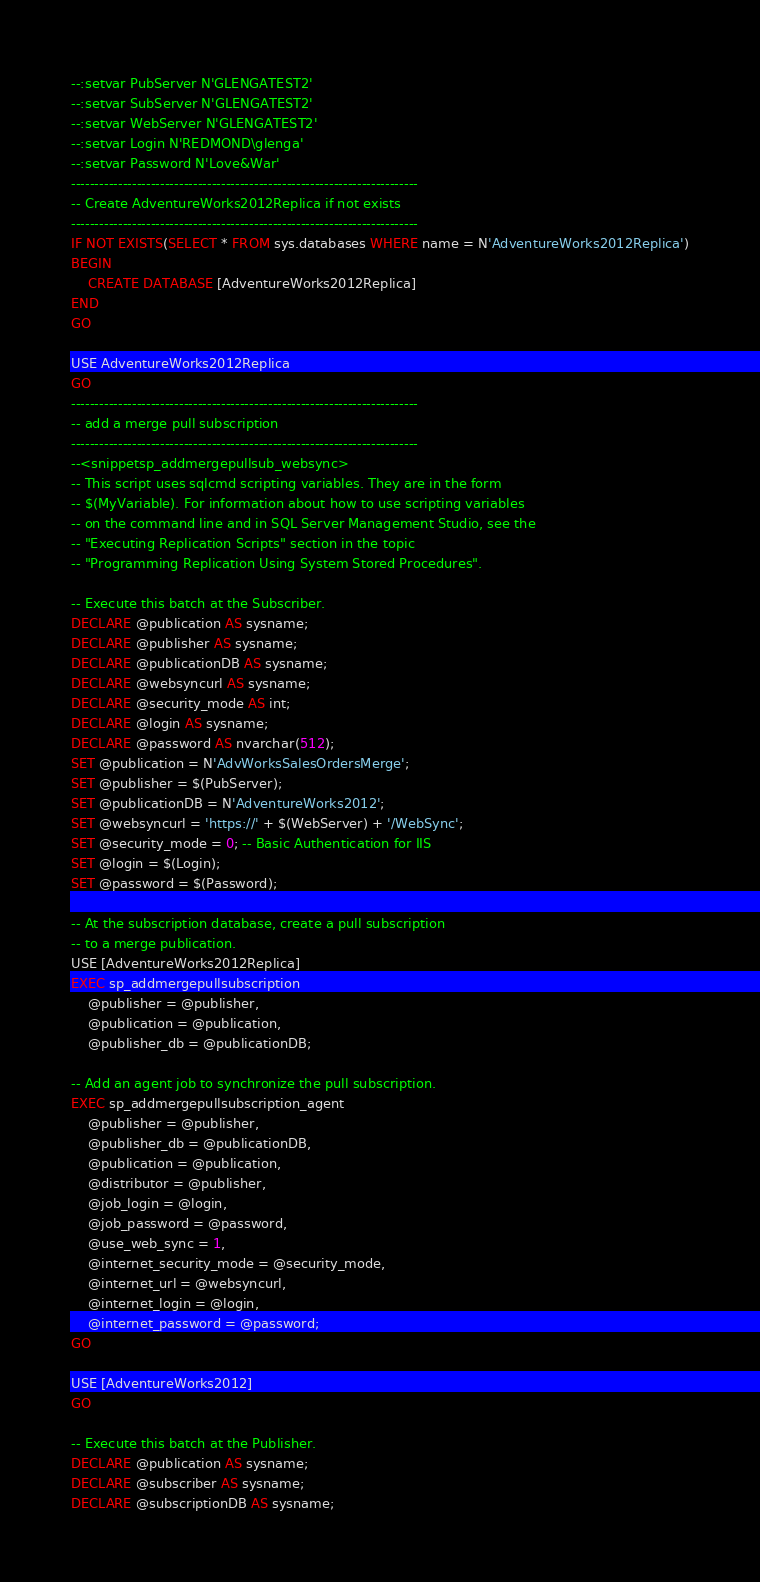<code> <loc_0><loc_0><loc_500><loc_500><_SQL_>--:setvar PubServer N'GLENGATEST2'
--:setvar SubServer N'GLENGATEST2'
--:setvar WebServer N'GLENGATEST2'
--:setvar Login N'REDMOND\glenga'
--:setvar Password N'Love&War'
--------------------------------------------------------------------------
-- Create AdventureWorks2012Replica if not exists
--------------------------------------------------------------------------
IF NOT EXISTS(SELECT * FROM sys.databases WHERE name = N'AdventureWorks2012Replica')
BEGIN
	CREATE DATABASE [AdventureWorks2012Replica]
END
GO

USE AdventureWorks2012Replica
GO
--------------------------------------------------------------------------
-- add a merge pull subscription
--------------------------------------------------------------------------
--<snippetsp_addmergepullsub_websync>
-- This script uses sqlcmd scripting variables. They are in the form
-- $(MyVariable). For information about how to use scripting variables  
-- on the command line and in SQL Server Management Studio, see the 
-- "Executing Replication Scripts" section in the topic
-- "Programming Replication Using System Stored Procedures".

-- Execute this batch at the Subscriber.
DECLARE @publication AS sysname;
DECLARE @publisher AS sysname;
DECLARE @publicationDB AS sysname;
DECLARE @websyncurl AS sysname;
DECLARE @security_mode AS int;
DECLARE @login AS sysname;
DECLARE @password AS nvarchar(512);
SET @publication = N'AdvWorksSalesOrdersMerge';
SET @publisher = $(PubServer);
SET @publicationDB = N'AdventureWorks2012';
SET @websyncurl = 'https://' + $(WebServer) + '/WebSync';
SET @security_mode = 0; -- Basic Authentication for IIS 
SET @login = $(Login);
SET @password = $(Password);

-- At the subscription database, create a pull subscription 
-- to a merge publication.
USE [AdventureWorks2012Replica]
EXEC sp_addmergepullsubscription 
	@publisher = @publisher, 
	@publication = @publication, 
	@publisher_db = @publicationDB;

-- Add an agent job to synchronize the pull subscription. 
EXEC sp_addmergepullsubscription_agent 
	@publisher = @publisher, 
	@publisher_db = @publicationDB, 
	@publication = @publication, 
	@distributor = @publisher, 
	@job_login = @login, 
	@job_password = @password,
	@use_web_sync = 1,
	@internet_security_mode = @security_mode,
	@internet_url = @websyncurl,
	@internet_login = @login,
	@internet_password = @password;
GO

USE [AdventureWorks2012]
GO

-- Execute this batch at the Publisher.
DECLARE @publication AS sysname;
DECLARE @subscriber AS sysname;
DECLARE @subscriptionDB AS sysname;</code> 